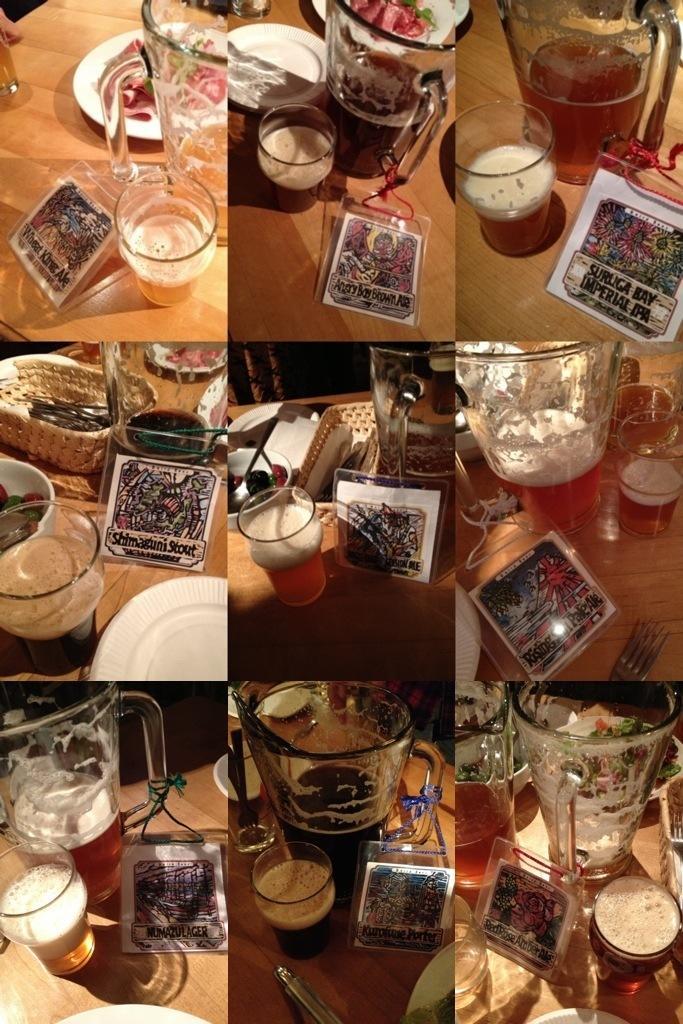Describe this image in one or two sentences. this image is a collage image, as we can see there are glasses, plates and tables as we can see in all these pictures in this image. 